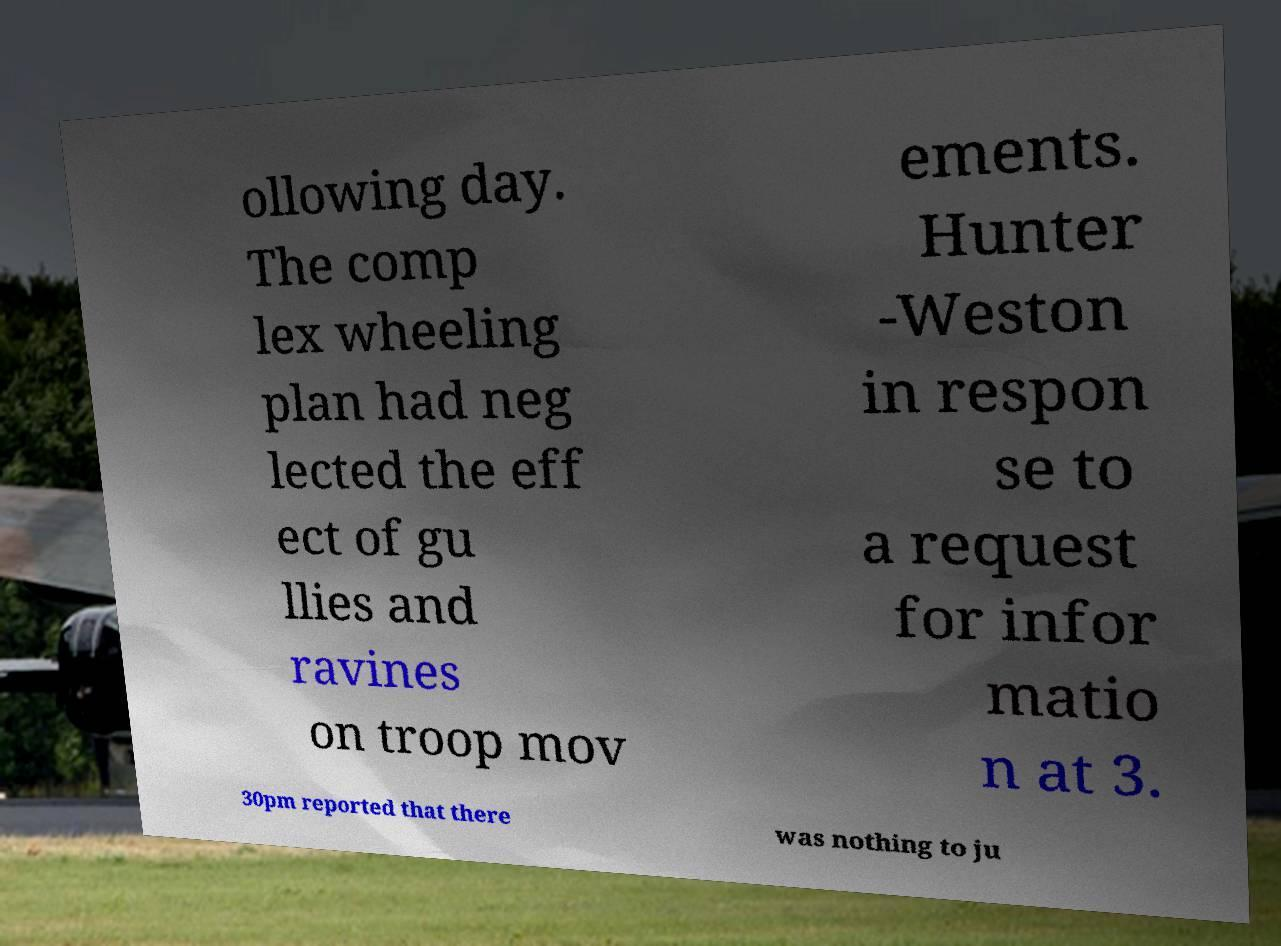Could you extract and type out the text from this image? ollowing day. The comp lex wheeling plan had neg lected the eff ect of gu llies and ravines on troop mov ements. Hunter -Weston in respon se to a request for infor matio n at 3. 30pm reported that there was nothing to ju 